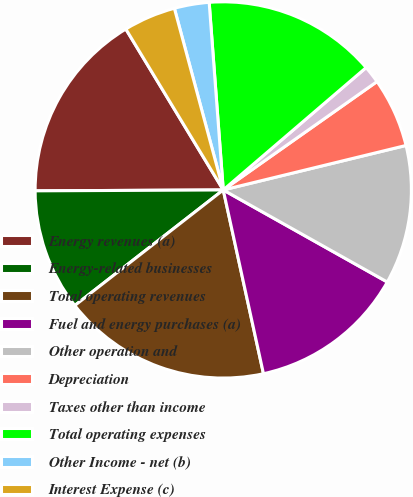Convert chart to OTSL. <chart><loc_0><loc_0><loc_500><loc_500><pie_chart><fcel>Energy revenues (a)<fcel>Energy-related businesses<fcel>Total operating revenues<fcel>Fuel and energy purchases (a)<fcel>Other operation and<fcel>Depreciation<fcel>Taxes other than income<fcel>Total operating expenses<fcel>Other Income - net (b)<fcel>Interest Expense (c)<nl><fcel>16.41%<fcel>10.45%<fcel>17.9%<fcel>13.43%<fcel>11.94%<fcel>5.97%<fcel>1.5%<fcel>14.92%<fcel>2.99%<fcel>4.48%<nl></chart> 